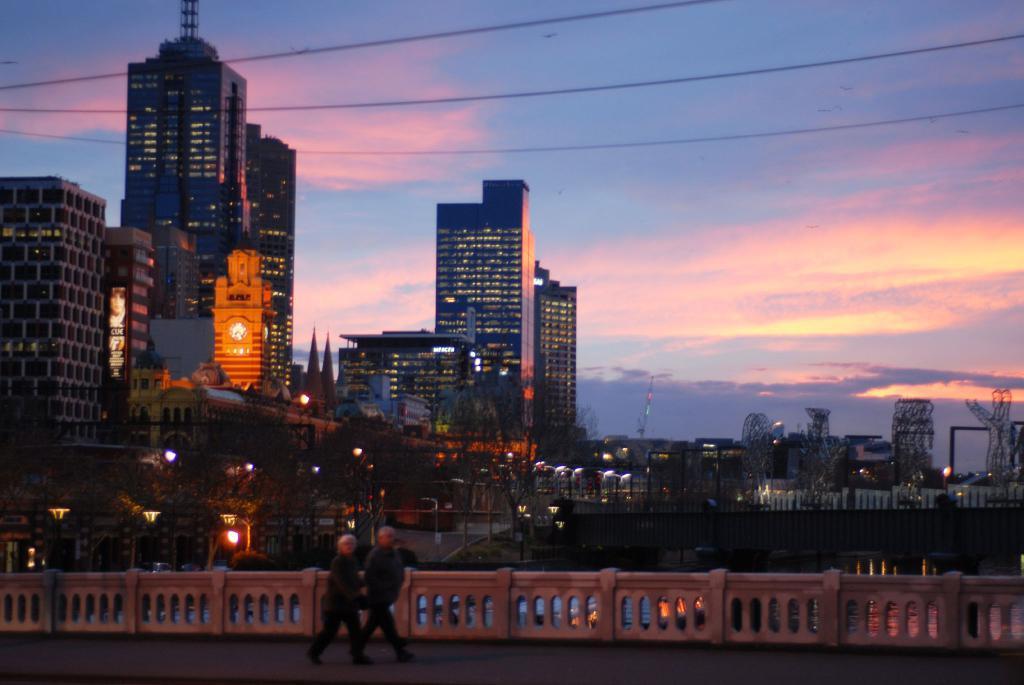Please provide a concise description of this image. In this picture we can see two people walking on the path. There is some fencing from left to right. We can see a few buildings, lights and wires on top. Sky is cloudy. 